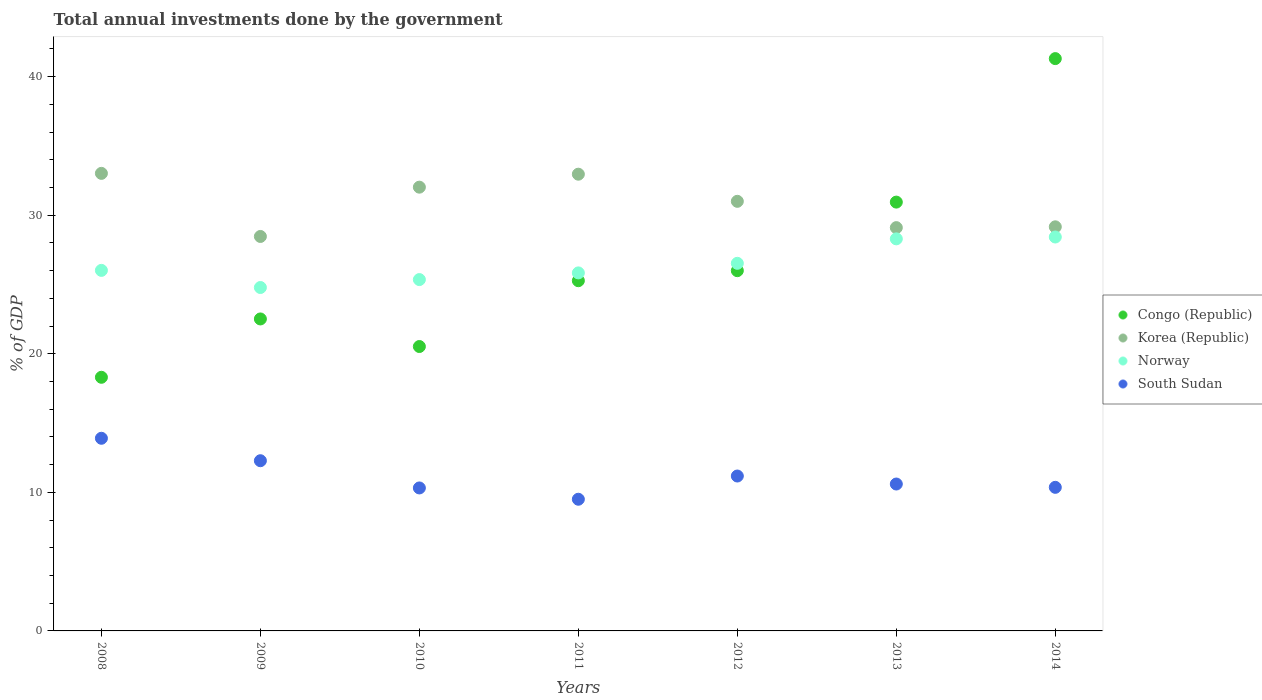Is the number of dotlines equal to the number of legend labels?
Ensure brevity in your answer.  Yes. What is the total annual investments done by the government in Congo (Republic) in 2014?
Your response must be concise. 41.3. Across all years, what is the maximum total annual investments done by the government in Korea (Republic)?
Offer a terse response. 33.02. Across all years, what is the minimum total annual investments done by the government in Congo (Republic)?
Keep it short and to the point. 18.3. In which year was the total annual investments done by the government in Congo (Republic) maximum?
Keep it short and to the point. 2014. What is the total total annual investments done by the government in South Sudan in the graph?
Give a very brief answer. 78.14. What is the difference between the total annual investments done by the government in Congo (Republic) in 2010 and that in 2013?
Offer a terse response. -10.42. What is the difference between the total annual investments done by the government in Congo (Republic) in 2013 and the total annual investments done by the government in Norway in 2014?
Your answer should be compact. 2.52. What is the average total annual investments done by the government in Korea (Republic) per year?
Your answer should be compact. 30.82. In the year 2009, what is the difference between the total annual investments done by the government in Korea (Republic) and total annual investments done by the government in Norway?
Your answer should be compact. 3.68. What is the ratio of the total annual investments done by the government in Norway in 2010 to that in 2011?
Your response must be concise. 0.98. Is the difference between the total annual investments done by the government in Korea (Republic) in 2009 and 2014 greater than the difference between the total annual investments done by the government in Norway in 2009 and 2014?
Provide a succinct answer. Yes. What is the difference between the highest and the second highest total annual investments done by the government in South Sudan?
Ensure brevity in your answer.  1.62. What is the difference between the highest and the lowest total annual investments done by the government in Norway?
Provide a succinct answer. 3.64. Is it the case that in every year, the sum of the total annual investments done by the government in Korea (Republic) and total annual investments done by the government in Norway  is greater than the total annual investments done by the government in South Sudan?
Give a very brief answer. Yes. Does the total annual investments done by the government in Norway monotonically increase over the years?
Your response must be concise. No. Is the total annual investments done by the government in Congo (Republic) strictly greater than the total annual investments done by the government in Korea (Republic) over the years?
Ensure brevity in your answer.  No. How many dotlines are there?
Give a very brief answer. 4. Does the graph contain any zero values?
Ensure brevity in your answer.  No. Does the graph contain grids?
Give a very brief answer. No. Where does the legend appear in the graph?
Your answer should be compact. Center right. What is the title of the graph?
Your answer should be very brief. Total annual investments done by the government. Does "United States" appear as one of the legend labels in the graph?
Keep it short and to the point. No. What is the label or title of the X-axis?
Your answer should be compact. Years. What is the label or title of the Y-axis?
Keep it short and to the point. % of GDP. What is the % of GDP of Congo (Republic) in 2008?
Offer a very short reply. 18.3. What is the % of GDP of Korea (Republic) in 2008?
Provide a short and direct response. 33.02. What is the % of GDP of Norway in 2008?
Your answer should be very brief. 26.02. What is the % of GDP in South Sudan in 2008?
Provide a succinct answer. 13.9. What is the % of GDP of Congo (Republic) in 2009?
Make the answer very short. 22.51. What is the % of GDP in Korea (Republic) in 2009?
Your response must be concise. 28.47. What is the % of GDP in Norway in 2009?
Keep it short and to the point. 24.78. What is the % of GDP in South Sudan in 2009?
Your answer should be very brief. 12.28. What is the % of GDP in Congo (Republic) in 2010?
Ensure brevity in your answer.  20.52. What is the % of GDP of Korea (Republic) in 2010?
Your answer should be very brief. 32.02. What is the % of GDP of Norway in 2010?
Keep it short and to the point. 25.35. What is the % of GDP in South Sudan in 2010?
Give a very brief answer. 10.32. What is the % of GDP in Congo (Republic) in 2011?
Offer a terse response. 25.27. What is the % of GDP of Korea (Republic) in 2011?
Offer a terse response. 32.96. What is the % of GDP of Norway in 2011?
Provide a succinct answer. 25.84. What is the % of GDP of South Sudan in 2011?
Your answer should be compact. 9.5. What is the % of GDP of Congo (Republic) in 2012?
Give a very brief answer. 26. What is the % of GDP in Korea (Republic) in 2012?
Your answer should be very brief. 31. What is the % of GDP of Norway in 2012?
Offer a very short reply. 26.53. What is the % of GDP of South Sudan in 2012?
Provide a short and direct response. 11.18. What is the % of GDP in Congo (Republic) in 2013?
Provide a succinct answer. 30.94. What is the % of GDP in Korea (Republic) in 2013?
Offer a very short reply. 29.1. What is the % of GDP of Norway in 2013?
Provide a succinct answer. 28.29. What is the % of GDP of South Sudan in 2013?
Provide a succinct answer. 10.6. What is the % of GDP in Congo (Republic) in 2014?
Ensure brevity in your answer.  41.3. What is the % of GDP of Korea (Republic) in 2014?
Your answer should be compact. 29.16. What is the % of GDP in Norway in 2014?
Your answer should be very brief. 28.43. What is the % of GDP in South Sudan in 2014?
Make the answer very short. 10.36. Across all years, what is the maximum % of GDP of Congo (Republic)?
Provide a succinct answer. 41.3. Across all years, what is the maximum % of GDP in Korea (Republic)?
Offer a very short reply. 33.02. Across all years, what is the maximum % of GDP of Norway?
Provide a short and direct response. 28.43. Across all years, what is the maximum % of GDP in South Sudan?
Offer a terse response. 13.9. Across all years, what is the minimum % of GDP of Congo (Republic)?
Keep it short and to the point. 18.3. Across all years, what is the minimum % of GDP of Korea (Republic)?
Ensure brevity in your answer.  28.47. Across all years, what is the minimum % of GDP in Norway?
Provide a short and direct response. 24.78. Across all years, what is the minimum % of GDP in South Sudan?
Offer a terse response. 9.5. What is the total % of GDP of Congo (Republic) in the graph?
Give a very brief answer. 184.85. What is the total % of GDP of Korea (Republic) in the graph?
Offer a very short reply. 215.73. What is the total % of GDP in Norway in the graph?
Provide a succinct answer. 185.23. What is the total % of GDP of South Sudan in the graph?
Give a very brief answer. 78.14. What is the difference between the % of GDP of Congo (Republic) in 2008 and that in 2009?
Offer a terse response. -4.21. What is the difference between the % of GDP in Korea (Republic) in 2008 and that in 2009?
Keep it short and to the point. 4.55. What is the difference between the % of GDP in Norway in 2008 and that in 2009?
Ensure brevity in your answer.  1.24. What is the difference between the % of GDP in South Sudan in 2008 and that in 2009?
Your answer should be very brief. 1.62. What is the difference between the % of GDP in Congo (Republic) in 2008 and that in 2010?
Make the answer very short. -2.22. What is the difference between the % of GDP of Norway in 2008 and that in 2010?
Your answer should be compact. 0.66. What is the difference between the % of GDP of South Sudan in 2008 and that in 2010?
Give a very brief answer. 3.58. What is the difference between the % of GDP of Congo (Republic) in 2008 and that in 2011?
Provide a short and direct response. -6.97. What is the difference between the % of GDP in Korea (Republic) in 2008 and that in 2011?
Provide a short and direct response. 0.06. What is the difference between the % of GDP in Norway in 2008 and that in 2011?
Provide a succinct answer. 0.18. What is the difference between the % of GDP in South Sudan in 2008 and that in 2011?
Offer a terse response. 4.4. What is the difference between the % of GDP in Congo (Republic) in 2008 and that in 2012?
Give a very brief answer. -7.69. What is the difference between the % of GDP of Korea (Republic) in 2008 and that in 2012?
Offer a very short reply. 2.02. What is the difference between the % of GDP of Norway in 2008 and that in 2012?
Offer a very short reply. -0.51. What is the difference between the % of GDP of South Sudan in 2008 and that in 2012?
Your answer should be compact. 2.72. What is the difference between the % of GDP of Congo (Republic) in 2008 and that in 2013?
Make the answer very short. -12.64. What is the difference between the % of GDP of Korea (Republic) in 2008 and that in 2013?
Offer a terse response. 3.92. What is the difference between the % of GDP of Norway in 2008 and that in 2013?
Offer a terse response. -2.27. What is the difference between the % of GDP in South Sudan in 2008 and that in 2013?
Give a very brief answer. 3.3. What is the difference between the % of GDP of Congo (Republic) in 2008 and that in 2014?
Your answer should be very brief. -23. What is the difference between the % of GDP in Korea (Republic) in 2008 and that in 2014?
Offer a terse response. 3.86. What is the difference between the % of GDP of Norway in 2008 and that in 2014?
Make the answer very short. -2.41. What is the difference between the % of GDP of South Sudan in 2008 and that in 2014?
Offer a very short reply. 3.54. What is the difference between the % of GDP of Congo (Republic) in 2009 and that in 2010?
Your answer should be compact. 1.99. What is the difference between the % of GDP of Korea (Republic) in 2009 and that in 2010?
Your answer should be very brief. -3.56. What is the difference between the % of GDP in Norway in 2009 and that in 2010?
Ensure brevity in your answer.  -0.57. What is the difference between the % of GDP of South Sudan in 2009 and that in 2010?
Offer a very short reply. 1.97. What is the difference between the % of GDP of Congo (Republic) in 2009 and that in 2011?
Your answer should be compact. -2.76. What is the difference between the % of GDP in Korea (Republic) in 2009 and that in 2011?
Your answer should be very brief. -4.49. What is the difference between the % of GDP in Norway in 2009 and that in 2011?
Your response must be concise. -1.05. What is the difference between the % of GDP in South Sudan in 2009 and that in 2011?
Make the answer very short. 2.78. What is the difference between the % of GDP in Congo (Republic) in 2009 and that in 2012?
Keep it short and to the point. -3.48. What is the difference between the % of GDP in Korea (Republic) in 2009 and that in 2012?
Your answer should be very brief. -2.54. What is the difference between the % of GDP of Norway in 2009 and that in 2012?
Your answer should be compact. -1.75. What is the difference between the % of GDP of South Sudan in 2009 and that in 2012?
Keep it short and to the point. 1.1. What is the difference between the % of GDP of Congo (Republic) in 2009 and that in 2013?
Make the answer very short. -8.43. What is the difference between the % of GDP in Korea (Republic) in 2009 and that in 2013?
Your response must be concise. -0.64. What is the difference between the % of GDP of Norway in 2009 and that in 2013?
Keep it short and to the point. -3.51. What is the difference between the % of GDP in South Sudan in 2009 and that in 2013?
Keep it short and to the point. 1.68. What is the difference between the % of GDP of Congo (Republic) in 2009 and that in 2014?
Ensure brevity in your answer.  -18.79. What is the difference between the % of GDP of Korea (Republic) in 2009 and that in 2014?
Provide a succinct answer. -0.7. What is the difference between the % of GDP of Norway in 2009 and that in 2014?
Keep it short and to the point. -3.64. What is the difference between the % of GDP of South Sudan in 2009 and that in 2014?
Your response must be concise. 1.92. What is the difference between the % of GDP in Congo (Republic) in 2010 and that in 2011?
Your answer should be very brief. -4.75. What is the difference between the % of GDP in Korea (Republic) in 2010 and that in 2011?
Offer a very short reply. -0.94. What is the difference between the % of GDP in Norway in 2010 and that in 2011?
Your response must be concise. -0.48. What is the difference between the % of GDP in South Sudan in 2010 and that in 2011?
Give a very brief answer. 0.82. What is the difference between the % of GDP of Congo (Republic) in 2010 and that in 2012?
Your answer should be compact. -5.47. What is the difference between the % of GDP in Korea (Republic) in 2010 and that in 2012?
Your response must be concise. 1.02. What is the difference between the % of GDP of Norway in 2010 and that in 2012?
Your response must be concise. -1.17. What is the difference between the % of GDP in South Sudan in 2010 and that in 2012?
Provide a succinct answer. -0.86. What is the difference between the % of GDP of Congo (Republic) in 2010 and that in 2013?
Provide a succinct answer. -10.42. What is the difference between the % of GDP of Korea (Republic) in 2010 and that in 2013?
Provide a short and direct response. 2.92. What is the difference between the % of GDP of Norway in 2010 and that in 2013?
Provide a short and direct response. -2.94. What is the difference between the % of GDP of South Sudan in 2010 and that in 2013?
Offer a very short reply. -0.28. What is the difference between the % of GDP of Congo (Republic) in 2010 and that in 2014?
Make the answer very short. -20.78. What is the difference between the % of GDP in Korea (Republic) in 2010 and that in 2014?
Make the answer very short. 2.86. What is the difference between the % of GDP of Norway in 2010 and that in 2014?
Your answer should be very brief. -3.07. What is the difference between the % of GDP of South Sudan in 2010 and that in 2014?
Provide a succinct answer. -0.04. What is the difference between the % of GDP of Congo (Republic) in 2011 and that in 2012?
Your answer should be very brief. -0.72. What is the difference between the % of GDP of Korea (Republic) in 2011 and that in 2012?
Give a very brief answer. 1.96. What is the difference between the % of GDP in Norway in 2011 and that in 2012?
Your answer should be very brief. -0.69. What is the difference between the % of GDP in South Sudan in 2011 and that in 2012?
Your answer should be compact. -1.68. What is the difference between the % of GDP in Congo (Republic) in 2011 and that in 2013?
Make the answer very short. -5.67. What is the difference between the % of GDP of Korea (Republic) in 2011 and that in 2013?
Give a very brief answer. 3.86. What is the difference between the % of GDP of Norway in 2011 and that in 2013?
Keep it short and to the point. -2.46. What is the difference between the % of GDP of South Sudan in 2011 and that in 2013?
Offer a terse response. -1.1. What is the difference between the % of GDP in Congo (Republic) in 2011 and that in 2014?
Offer a terse response. -16.03. What is the difference between the % of GDP in Korea (Republic) in 2011 and that in 2014?
Your response must be concise. 3.8. What is the difference between the % of GDP of Norway in 2011 and that in 2014?
Make the answer very short. -2.59. What is the difference between the % of GDP of South Sudan in 2011 and that in 2014?
Your answer should be compact. -0.86. What is the difference between the % of GDP of Congo (Republic) in 2012 and that in 2013?
Keep it short and to the point. -4.95. What is the difference between the % of GDP in Korea (Republic) in 2012 and that in 2013?
Your answer should be very brief. 1.9. What is the difference between the % of GDP of Norway in 2012 and that in 2013?
Your response must be concise. -1.76. What is the difference between the % of GDP in South Sudan in 2012 and that in 2013?
Make the answer very short. 0.58. What is the difference between the % of GDP in Congo (Republic) in 2012 and that in 2014?
Keep it short and to the point. -15.3. What is the difference between the % of GDP of Korea (Republic) in 2012 and that in 2014?
Offer a terse response. 1.84. What is the difference between the % of GDP of Norway in 2012 and that in 2014?
Offer a very short reply. -1.9. What is the difference between the % of GDP in South Sudan in 2012 and that in 2014?
Offer a very short reply. 0.82. What is the difference between the % of GDP of Congo (Republic) in 2013 and that in 2014?
Your answer should be very brief. -10.36. What is the difference between the % of GDP in Korea (Republic) in 2013 and that in 2014?
Ensure brevity in your answer.  -0.06. What is the difference between the % of GDP of Norway in 2013 and that in 2014?
Ensure brevity in your answer.  -0.13. What is the difference between the % of GDP in South Sudan in 2013 and that in 2014?
Provide a short and direct response. 0.24. What is the difference between the % of GDP of Congo (Republic) in 2008 and the % of GDP of Korea (Republic) in 2009?
Your answer should be compact. -10.16. What is the difference between the % of GDP in Congo (Republic) in 2008 and the % of GDP in Norway in 2009?
Your response must be concise. -6.48. What is the difference between the % of GDP of Congo (Republic) in 2008 and the % of GDP of South Sudan in 2009?
Offer a terse response. 6.02. What is the difference between the % of GDP in Korea (Republic) in 2008 and the % of GDP in Norway in 2009?
Offer a very short reply. 8.24. What is the difference between the % of GDP of Korea (Republic) in 2008 and the % of GDP of South Sudan in 2009?
Your answer should be compact. 20.74. What is the difference between the % of GDP of Norway in 2008 and the % of GDP of South Sudan in 2009?
Your response must be concise. 13.74. What is the difference between the % of GDP in Congo (Republic) in 2008 and the % of GDP in Korea (Republic) in 2010?
Offer a very short reply. -13.72. What is the difference between the % of GDP in Congo (Republic) in 2008 and the % of GDP in Norway in 2010?
Ensure brevity in your answer.  -7.05. What is the difference between the % of GDP of Congo (Republic) in 2008 and the % of GDP of South Sudan in 2010?
Ensure brevity in your answer.  7.99. What is the difference between the % of GDP of Korea (Republic) in 2008 and the % of GDP of Norway in 2010?
Keep it short and to the point. 7.66. What is the difference between the % of GDP of Korea (Republic) in 2008 and the % of GDP of South Sudan in 2010?
Offer a terse response. 22.7. What is the difference between the % of GDP in Norway in 2008 and the % of GDP in South Sudan in 2010?
Give a very brief answer. 15.7. What is the difference between the % of GDP in Congo (Republic) in 2008 and the % of GDP in Korea (Republic) in 2011?
Make the answer very short. -14.66. What is the difference between the % of GDP in Congo (Republic) in 2008 and the % of GDP in Norway in 2011?
Provide a short and direct response. -7.53. What is the difference between the % of GDP in Congo (Republic) in 2008 and the % of GDP in South Sudan in 2011?
Ensure brevity in your answer.  8.8. What is the difference between the % of GDP in Korea (Republic) in 2008 and the % of GDP in Norway in 2011?
Offer a very short reply. 7.18. What is the difference between the % of GDP in Korea (Republic) in 2008 and the % of GDP in South Sudan in 2011?
Give a very brief answer. 23.52. What is the difference between the % of GDP in Norway in 2008 and the % of GDP in South Sudan in 2011?
Make the answer very short. 16.52. What is the difference between the % of GDP of Congo (Republic) in 2008 and the % of GDP of Korea (Republic) in 2012?
Make the answer very short. -12.7. What is the difference between the % of GDP in Congo (Republic) in 2008 and the % of GDP in Norway in 2012?
Provide a succinct answer. -8.22. What is the difference between the % of GDP in Congo (Republic) in 2008 and the % of GDP in South Sudan in 2012?
Your answer should be very brief. 7.13. What is the difference between the % of GDP of Korea (Republic) in 2008 and the % of GDP of Norway in 2012?
Your answer should be compact. 6.49. What is the difference between the % of GDP in Korea (Republic) in 2008 and the % of GDP in South Sudan in 2012?
Your answer should be very brief. 21.84. What is the difference between the % of GDP of Norway in 2008 and the % of GDP of South Sudan in 2012?
Offer a terse response. 14.84. What is the difference between the % of GDP in Congo (Republic) in 2008 and the % of GDP in Korea (Republic) in 2013?
Make the answer very short. -10.8. What is the difference between the % of GDP in Congo (Republic) in 2008 and the % of GDP in Norway in 2013?
Provide a succinct answer. -9.99. What is the difference between the % of GDP in Congo (Republic) in 2008 and the % of GDP in South Sudan in 2013?
Make the answer very short. 7.7. What is the difference between the % of GDP in Korea (Republic) in 2008 and the % of GDP in Norway in 2013?
Keep it short and to the point. 4.73. What is the difference between the % of GDP in Korea (Republic) in 2008 and the % of GDP in South Sudan in 2013?
Provide a succinct answer. 22.42. What is the difference between the % of GDP in Norway in 2008 and the % of GDP in South Sudan in 2013?
Give a very brief answer. 15.42. What is the difference between the % of GDP in Congo (Republic) in 2008 and the % of GDP in Korea (Republic) in 2014?
Provide a succinct answer. -10.86. What is the difference between the % of GDP in Congo (Republic) in 2008 and the % of GDP in Norway in 2014?
Your response must be concise. -10.12. What is the difference between the % of GDP of Congo (Republic) in 2008 and the % of GDP of South Sudan in 2014?
Ensure brevity in your answer.  7.94. What is the difference between the % of GDP of Korea (Republic) in 2008 and the % of GDP of Norway in 2014?
Offer a terse response. 4.59. What is the difference between the % of GDP in Korea (Republic) in 2008 and the % of GDP in South Sudan in 2014?
Your answer should be very brief. 22.66. What is the difference between the % of GDP in Norway in 2008 and the % of GDP in South Sudan in 2014?
Your response must be concise. 15.66. What is the difference between the % of GDP of Congo (Republic) in 2009 and the % of GDP of Korea (Republic) in 2010?
Your answer should be compact. -9.51. What is the difference between the % of GDP in Congo (Republic) in 2009 and the % of GDP in Norway in 2010?
Keep it short and to the point. -2.84. What is the difference between the % of GDP in Congo (Republic) in 2009 and the % of GDP in South Sudan in 2010?
Give a very brief answer. 12.2. What is the difference between the % of GDP in Korea (Republic) in 2009 and the % of GDP in Norway in 2010?
Offer a very short reply. 3.11. What is the difference between the % of GDP in Korea (Republic) in 2009 and the % of GDP in South Sudan in 2010?
Your answer should be compact. 18.15. What is the difference between the % of GDP of Norway in 2009 and the % of GDP of South Sudan in 2010?
Make the answer very short. 14.46. What is the difference between the % of GDP in Congo (Republic) in 2009 and the % of GDP in Korea (Republic) in 2011?
Make the answer very short. -10.45. What is the difference between the % of GDP of Congo (Republic) in 2009 and the % of GDP of Norway in 2011?
Provide a succinct answer. -3.32. What is the difference between the % of GDP in Congo (Republic) in 2009 and the % of GDP in South Sudan in 2011?
Your answer should be compact. 13.01. What is the difference between the % of GDP in Korea (Republic) in 2009 and the % of GDP in Norway in 2011?
Give a very brief answer. 2.63. What is the difference between the % of GDP in Korea (Republic) in 2009 and the % of GDP in South Sudan in 2011?
Provide a succinct answer. 18.96. What is the difference between the % of GDP in Norway in 2009 and the % of GDP in South Sudan in 2011?
Keep it short and to the point. 15.28. What is the difference between the % of GDP of Congo (Republic) in 2009 and the % of GDP of Korea (Republic) in 2012?
Offer a very short reply. -8.49. What is the difference between the % of GDP in Congo (Republic) in 2009 and the % of GDP in Norway in 2012?
Your answer should be very brief. -4.01. What is the difference between the % of GDP in Congo (Republic) in 2009 and the % of GDP in South Sudan in 2012?
Keep it short and to the point. 11.34. What is the difference between the % of GDP in Korea (Republic) in 2009 and the % of GDP in Norway in 2012?
Offer a very short reply. 1.94. What is the difference between the % of GDP of Korea (Republic) in 2009 and the % of GDP of South Sudan in 2012?
Give a very brief answer. 17.29. What is the difference between the % of GDP in Norway in 2009 and the % of GDP in South Sudan in 2012?
Ensure brevity in your answer.  13.6. What is the difference between the % of GDP in Congo (Republic) in 2009 and the % of GDP in Korea (Republic) in 2013?
Ensure brevity in your answer.  -6.59. What is the difference between the % of GDP of Congo (Republic) in 2009 and the % of GDP of Norway in 2013?
Offer a very short reply. -5.78. What is the difference between the % of GDP of Congo (Republic) in 2009 and the % of GDP of South Sudan in 2013?
Give a very brief answer. 11.91. What is the difference between the % of GDP in Korea (Republic) in 2009 and the % of GDP in Norway in 2013?
Provide a succinct answer. 0.17. What is the difference between the % of GDP of Korea (Republic) in 2009 and the % of GDP of South Sudan in 2013?
Keep it short and to the point. 17.86. What is the difference between the % of GDP in Norway in 2009 and the % of GDP in South Sudan in 2013?
Your answer should be compact. 14.18. What is the difference between the % of GDP of Congo (Republic) in 2009 and the % of GDP of Korea (Republic) in 2014?
Your response must be concise. -6.65. What is the difference between the % of GDP in Congo (Republic) in 2009 and the % of GDP in Norway in 2014?
Provide a succinct answer. -5.91. What is the difference between the % of GDP of Congo (Republic) in 2009 and the % of GDP of South Sudan in 2014?
Give a very brief answer. 12.15. What is the difference between the % of GDP of Korea (Republic) in 2009 and the % of GDP of Norway in 2014?
Provide a succinct answer. 0.04. What is the difference between the % of GDP in Korea (Republic) in 2009 and the % of GDP in South Sudan in 2014?
Keep it short and to the point. 18.1. What is the difference between the % of GDP of Norway in 2009 and the % of GDP of South Sudan in 2014?
Your answer should be compact. 14.42. What is the difference between the % of GDP of Congo (Republic) in 2010 and the % of GDP of Korea (Republic) in 2011?
Your answer should be very brief. -12.44. What is the difference between the % of GDP of Congo (Republic) in 2010 and the % of GDP of Norway in 2011?
Offer a terse response. -5.31. What is the difference between the % of GDP of Congo (Republic) in 2010 and the % of GDP of South Sudan in 2011?
Give a very brief answer. 11.02. What is the difference between the % of GDP of Korea (Republic) in 2010 and the % of GDP of Norway in 2011?
Provide a short and direct response. 6.19. What is the difference between the % of GDP of Korea (Republic) in 2010 and the % of GDP of South Sudan in 2011?
Provide a short and direct response. 22.52. What is the difference between the % of GDP of Norway in 2010 and the % of GDP of South Sudan in 2011?
Offer a very short reply. 15.85. What is the difference between the % of GDP of Congo (Republic) in 2010 and the % of GDP of Korea (Republic) in 2012?
Give a very brief answer. -10.48. What is the difference between the % of GDP of Congo (Republic) in 2010 and the % of GDP of Norway in 2012?
Ensure brevity in your answer.  -6. What is the difference between the % of GDP of Congo (Republic) in 2010 and the % of GDP of South Sudan in 2012?
Offer a very short reply. 9.35. What is the difference between the % of GDP in Korea (Republic) in 2010 and the % of GDP in Norway in 2012?
Provide a succinct answer. 5.5. What is the difference between the % of GDP in Korea (Republic) in 2010 and the % of GDP in South Sudan in 2012?
Your answer should be very brief. 20.85. What is the difference between the % of GDP in Norway in 2010 and the % of GDP in South Sudan in 2012?
Provide a succinct answer. 14.18. What is the difference between the % of GDP in Congo (Republic) in 2010 and the % of GDP in Korea (Republic) in 2013?
Your answer should be compact. -8.58. What is the difference between the % of GDP in Congo (Republic) in 2010 and the % of GDP in Norway in 2013?
Your answer should be very brief. -7.77. What is the difference between the % of GDP in Congo (Republic) in 2010 and the % of GDP in South Sudan in 2013?
Keep it short and to the point. 9.92. What is the difference between the % of GDP in Korea (Republic) in 2010 and the % of GDP in Norway in 2013?
Keep it short and to the point. 3.73. What is the difference between the % of GDP in Korea (Republic) in 2010 and the % of GDP in South Sudan in 2013?
Make the answer very short. 21.42. What is the difference between the % of GDP in Norway in 2010 and the % of GDP in South Sudan in 2013?
Your response must be concise. 14.75. What is the difference between the % of GDP in Congo (Republic) in 2010 and the % of GDP in Korea (Republic) in 2014?
Keep it short and to the point. -8.64. What is the difference between the % of GDP of Congo (Republic) in 2010 and the % of GDP of Norway in 2014?
Make the answer very short. -7.9. What is the difference between the % of GDP in Congo (Republic) in 2010 and the % of GDP in South Sudan in 2014?
Make the answer very short. 10.16. What is the difference between the % of GDP in Korea (Republic) in 2010 and the % of GDP in Norway in 2014?
Your answer should be compact. 3.6. What is the difference between the % of GDP in Korea (Republic) in 2010 and the % of GDP in South Sudan in 2014?
Give a very brief answer. 21.66. What is the difference between the % of GDP in Norway in 2010 and the % of GDP in South Sudan in 2014?
Give a very brief answer. 14.99. What is the difference between the % of GDP of Congo (Republic) in 2011 and the % of GDP of Korea (Republic) in 2012?
Provide a short and direct response. -5.73. What is the difference between the % of GDP of Congo (Republic) in 2011 and the % of GDP of Norway in 2012?
Your response must be concise. -1.26. What is the difference between the % of GDP in Congo (Republic) in 2011 and the % of GDP in South Sudan in 2012?
Offer a terse response. 14.09. What is the difference between the % of GDP in Korea (Republic) in 2011 and the % of GDP in Norway in 2012?
Your response must be concise. 6.43. What is the difference between the % of GDP in Korea (Republic) in 2011 and the % of GDP in South Sudan in 2012?
Offer a terse response. 21.78. What is the difference between the % of GDP in Norway in 2011 and the % of GDP in South Sudan in 2012?
Give a very brief answer. 14.66. What is the difference between the % of GDP of Congo (Republic) in 2011 and the % of GDP of Korea (Republic) in 2013?
Offer a terse response. -3.83. What is the difference between the % of GDP of Congo (Republic) in 2011 and the % of GDP of Norway in 2013?
Ensure brevity in your answer.  -3.02. What is the difference between the % of GDP of Congo (Republic) in 2011 and the % of GDP of South Sudan in 2013?
Ensure brevity in your answer.  14.67. What is the difference between the % of GDP in Korea (Republic) in 2011 and the % of GDP in Norway in 2013?
Offer a very short reply. 4.67. What is the difference between the % of GDP of Korea (Republic) in 2011 and the % of GDP of South Sudan in 2013?
Provide a succinct answer. 22.36. What is the difference between the % of GDP of Norway in 2011 and the % of GDP of South Sudan in 2013?
Make the answer very short. 15.23. What is the difference between the % of GDP of Congo (Republic) in 2011 and the % of GDP of Korea (Republic) in 2014?
Your response must be concise. -3.89. What is the difference between the % of GDP in Congo (Republic) in 2011 and the % of GDP in Norway in 2014?
Provide a succinct answer. -3.15. What is the difference between the % of GDP of Congo (Republic) in 2011 and the % of GDP of South Sudan in 2014?
Give a very brief answer. 14.91. What is the difference between the % of GDP of Korea (Republic) in 2011 and the % of GDP of Norway in 2014?
Your answer should be compact. 4.53. What is the difference between the % of GDP in Korea (Republic) in 2011 and the % of GDP in South Sudan in 2014?
Your response must be concise. 22.6. What is the difference between the % of GDP of Norway in 2011 and the % of GDP of South Sudan in 2014?
Your response must be concise. 15.47. What is the difference between the % of GDP of Congo (Republic) in 2012 and the % of GDP of Korea (Republic) in 2013?
Offer a terse response. -3.11. What is the difference between the % of GDP in Congo (Republic) in 2012 and the % of GDP in Norway in 2013?
Provide a succinct answer. -2.3. What is the difference between the % of GDP of Congo (Republic) in 2012 and the % of GDP of South Sudan in 2013?
Provide a short and direct response. 15.4. What is the difference between the % of GDP in Korea (Republic) in 2012 and the % of GDP in Norway in 2013?
Provide a short and direct response. 2.71. What is the difference between the % of GDP of Korea (Republic) in 2012 and the % of GDP of South Sudan in 2013?
Make the answer very short. 20.4. What is the difference between the % of GDP of Norway in 2012 and the % of GDP of South Sudan in 2013?
Keep it short and to the point. 15.93. What is the difference between the % of GDP of Congo (Republic) in 2012 and the % of GDP of Korea (Republic) in 2014?
Provide a succinct answer. -3.16. What is the difference between the % of GDP in Congo (Republic) in 2012 and the % of GDP in Norway in 2014?
Provide a succinct answer. -2.43. What is the difference between the % of GDP in Congo (Republic) in 2012 and the % of GDP in South Sudan in 2014?
Keep it short and to the point. 15.63. What is the difference between the % of GDP in Korea (Republic) in 2012 and the % of GDP in Norway in 2014?
Ensure brevity in your answer.  2.58. What is the difference between the % of GDP in Korea (Republic) in 2012 and the % of GDP in South Sudan in 2014?
Ensure brevity in your answer.  20.64. What is the difference between the % of GDP of Norway in 2012 and the % of GDP of South Sudan in 2014?
Provide a short and direct response. 16.17. What is the difference between the % of GDP in Congo (Republic) in 2013 and the % of GDP in Korea (Republic) in 2014?
Your response must be concise. 1.78. What is the difference between the % of GDP of Congo (Republic) in 2013 and the % of GDP of Norway in 2014?
Give a very brief answer. 2.52. What is the difference between the % of GDP in Congo (Republic) in 2013 and the % of GDP in South Sudan in 2014?
Ensure brevity in your answer.  20.58. What is the difference between the % of GDP in Korea (Republic) in 2013 and the % of GDP in Norway in 2014?
Your response must be concise. 0.68. What is the difference between the % of GDP in Korea (Republic) in 2013 and the % of GDP in South Sudan in 2014?
Give a very brief answer. 18.74. What is the difference between the % of GDP of Norway in 2013 and the % of GDP of South Sudan in 2014?
Offer a terse response. 17.93. What is the average % of GDP in Congo (Republic) per year?
Your answer should be compact. 26.41. What is the average % of GDP in Korea (Republic) per year?
Offer a very short reply. 30.82. What is the average % of GDP of Norway per year?
Offer a very short reply. 26.46. What is the average % of GDP of South Sudan per year?
Your answer should be compact. 11.16. In the year 2008, what is the difference between the % of GDP in Congo (Republic) and % of GDP in Korea (Republic)?
Your answer should be compact. -14.72. In the year 2008, what is the difference between the % of GDP of Congo (Republic) and % of GDP of Norway?
Ensure brevity in your answer.  -7.71. In the year 2008, what is the difference between the % of GDP of Congo (Republic) and % of GDP of South Sudan?
Make the answer very short. 4.4. In the year 2008, what is the difference between the % of GDP of Korea (Republic) and % of GDP of Norway?
Offer a terse response. 7. In the year 2008, what is the difference between the % of GDP in Korea (Republic) and % of GDP in South Sudan?
Your answer should be compact. 19.12. In the year 2008, what is the difference between the % of GDP in Norway and % of GDP in South Sudan?
Ensure brevity in your answer.  12.12. In the year 2009, what is the difference between the % of GDP of Congo (Republic) and % of GDP of Korea (Republic)?
Give a very brief answer. -5.95. In the year 2009, what is the difference between the % of GDP of Congo (Republic) and % of GDP of Norway?
Make the answer very short. -2.27. In the year 2009, what is the difference between the % of GDP of Congo (Republic) and % of GDP of South Sudan?
Your answer should be very brief. 10.23. In the year 2009, what is the difference between the % of GDP in Korea (Republic) and % of GDP in Norway?
Provide a succinct answer. 3.68. In the year 2009, what is the difference between the % of GDP in Korea (Republic) and % of GDP in South Sudan?
Your answer should be compact. 16.18. In the year 2009, what is the difference between the % of GDP of Norway and % of GDP of South Sudan?
Provide a short and direct response. 12.5. In the year 2010, what is the difference between the % of GDP in Congo (Republic) and % of GDP in Korea (Republic)?
Make the answer very short. -11.5. In the year 2010, what is the difference between the % of GDP in Congo (Republic) and % of GDP in Norway?
Keep it short and to the point. -4.83. In the year 2010, what is the difference between the % of GDP of Congo (Republic) and % of GDP of South Sudan?
Make the answer very short. 10.21. In the year 2010, what is the difference between the % of GDP of Korea (Republic) and % of GDP of Norway?
Your answer should be very brief. 6.67. In the year 2010, what is the difference between the % of GDP in Korea (Republic) and % of GDP in South Sudan?
Provide a succinct answer. 21.71. In the year 2010, what is the difference between the % of GDP of Norway and % of GDP of South Sudan?
Offer a terse response. 15.04. In the year 2011, what is the difference between the % of GDP in Congo (Republic) and % of GDP in Korea (Republic)?
Ensure brevity in your answer.  -7.69. In the year 2011, what is the difference between the % of GDP of Congo (Republic) and % of GDP of Norway?
Your answer should be very brief. -0.56. In the year 2011, what is the difference between the % of GDP of Congo (Republic) and % of GDP of South Sudan?
Make the answer very short. 15.77. In the year 2011, what is the difference between the % of GDP in Korea (Republic) and % of GDP in Norway?
Your answer should be compact. 7.12. In the year 2011, what is the difference between the % of GDP in Korea (Republic) and % of GDP in South Sudan?
Offer a terse response. 23.46. In the year 2011, what is the difference between the % of GDP of Norway and % of GDP of South Sudan?
Provide a succinct answer. 16.33. In the year 2012, what is the difference between the % of GDP in Congo (Republic) and % of GDP in Korea (Republic)?
Ensure brevity in your answer.  -5. In the year 2012, what is the difference between the % of GDP of Congo (Republic) and % of GDP of Norway?
Your answer should be very brief. -0.53. In the year 2012, what is the difference between the % of GDP of Congo (Republic) and % of GDP of South Sudan?
Your answer should be very brief. 14.82. In the year 2012, what is the difference between the % of GDP in Korea (Republic) and % of GDP in Norway?
Give a very brief answer. 4.47. In the year 2012, what is the difference between the % of GDP of Korea (Republic) and % of GDP of South Sudan?
Offer a terse response. 19.82. In the year 2012, what is the difference between the % of GDP of Norway and % of GDP of South Sudan?
Make the answer very short. 15.35. In the year 2013, what is the difference between the % of GDP in Congo (Republic) and % of GDP in Korea (Republic)?
Ensure brevity in your answer.  1.84. In the year 2013, what is the difference between the % of GDP in Congo (Republic) and % of GDP in Norway?
Give a very brief answer. 2.65. In the year 2013, what is the difference between the % of GDP in Congo (Republic) and % of GDP in South Sudan?
Your answer should be very brief. 20.34. In the year 2013, what is the difference between the % of GDP in Korea (Republic) and % of GDP in Norway?
Offer a very short reply. 0.81. In the year 2013, what is the difference between the % of GDP in Korea (Republic) and % of GDP in South Sudan?
Keep it short and to the point. 18.5. In the year 2013, what is the difference between the % of GDP of Norway and % of GDP of South Sudan?
Offer a very short reply. 17.69. In the year 2014, what is the difference between the % of GDP in Congo (Republic) and % of GDP in Korea (Republic)?
Your answer should be compact. 12.14. In the year 2014, what is the difference between the % of GDP of Congo (Republic) and % of GDP of Norway?
Offer a terse response. 12.87. In the year 2014, what is the difference between the % of GDP of Congo (Republic) and % of GDP of South Sudan?
Your answer should be very brief. 30.94. In the year 2014, what is the difference between the % of GDP of Korea (Republic) and % of GDP of Norway?
Ensure brevity in your answer.  0.74. In the year 2014, what is the difference between the % of GDP of Korea (Republic) and % of GDP of South Sudan?
Your answer should be compact. 18.8. In the year 2014, what is the difference between the % of GDP in Norway and % of GDP in South Sudan?
Provide a short and direct response. 18.06. What is the ratio of the % of GDP of Congo (Republic) in 2008 to that in 2009?
Ensure brevity in your answer.  0.81. What is the ratio of the % of GDP of Korea (Republic) in 2008 to that in 2009?
Your response must be concise. 1.16. What is the ratio of the % of GDP in Norway in 2008 to that in 2009?
Offer a terse response. 1.05. What is the ratio of the % of GDP in South Sudan in 2008 to that in 2009?
Your answer should be very brief. 1.13. What is the ratio of the % of GDP of Congo (Republic) in 2008 to that in 2010?
Provide a short and direct response. 0.89. What is the ratio of the % of GDP of Korea (Republic) in 2008 to that in 2010?
Your answer should be compact. 1.03. What is the ratio of the % of GDP in Norway in 2008 to that in 2010?
Keep it short and to the point. 1.03. What is the ratio of the % of GDP in South Sudan in 2008 to that in 2010?
Your answer should be compact. 1.35. What is the ratio of the % of GDP of Congo (Republic) in 2008 to that in 2011?
Keep it short and to the point. 0.72. What is the ratio of the % of GDP in Korea (Republic) in 2008 to that in 2011?
Provide a succinct answer. 1. What is the ratio of the % of GDP in Norway in 2008 to that in 2011?
Your response must be concise. 1.01. What is the ratio of the % of GDP in South Sudan in 2008 to that in 2011?
Provide a succinct answer. 1.46. What is the ratio of the % of GDP in Congo (Republic) in 2008 to that in 2012?
Offer a very short reply. 0.7. What is the ratio of the % of GDP in Korea (Republic) in 2008 to that in 2012?
Your answer should be compact. 1.07. What is the ratio of the % of GDP of Norway in 2008 to that in 2012?
Provide a succinct answer. 0.98. What is the ratio of the % of GDP in South Sudan in 2008 to that in 2012?
Give a very brief answer. 1.24. What is the ratio of the % of GDP of Congo (Republic) in 2008 to that in 2013?
Give a very brief answer. 0.59. What is the ratio of the % of GDP in Korea (Republic) in 2008 to that in 2013?
Make the answer very short. 1.13. What is the ratio of the % of GDP of Norway in 2008 to that in 2013?
Make the answer very short. 0.92. What is the ratio of the % of GDP in South Sudan in 2008 to that in 2013?
Make the answer very short. 1.31. What is the ratio of the % of GDP in Congo (Republic) in 2008 to that in 2014?
Make the answer very short. 0.44. What is the ratio of the % of GDP in Korea (Republic) in 2008 to that in 2014?
Provide a short and direct response. 1.13. What is the ratio of the % of GDP of Norway in 2008 to that in 2014?
Make the answer very short. 0.92. What is the ratio of the % of GDP in South Sudan in 2008 to that in 2014?
Your answer should be very brief. 1.34. What is the ratio of the % of GDP in Congo (Republic) in 2009 to that in 2010?
Your answer should be compact. 1.1. What is the ratio of the % of GDP in Korea (Republic) in 2009 to that in 2010?
Offer a terse response. 0.89. What is the ratio of the % of GDP in Norway in 2009 to that in 2010?
Offer a very short reply. 0.98. What is the ratio of the % of GDP in South Sudan in 2009 to that in 2010?
Offer a terse response. 1.19. What is the ratio of the % of GDP of Congo (Republic) in 2009 to that in 2011?
Make the answer very short. 0.89. What is the ratio of the % of GDP of Korea (Republic) in 2009 to that in 2011?
Offer a very short reply. 0.86. What is the ratio of the % of GDP of Norway in 2009 to that in 2011?
Your response must be concise. 0.96. What is the ratio of the % of GDP in South Sudan in 2009 to that in 2011?
Make the answer very short. 1.29. What is the ratio of the % of GDP of Congo (Republic) in 2009 to that in 2012?
Your response must be concise. 0.87. What is the ratio of the % of GDP of Korea (Republic) in 2009 to that in 2012?
Offer a very short reply. 0.92. What is the ratio of the % of GDP of Norway in 2009 to that in 2012?
Provide a short and direct response. 0.93. What is the ratio of the % of GDP of South Sudan in 2009 to that in 2012?
Ensure brevity in your answer.  1.1. What is the ratio of the % of GDP of Congo (Republic) in 2009 to that in 2013?
Provide a succinct answer. 0.73. What is the ratio of the % of GDP in Korea (Republic) in 2009 to that in 2013?
Keep it short and to the point. 0.98. What is the ratio of the % of GDP of Norway in 2009 to that in 2013?
Make the answer very short. 0.88. What is the ratio of the % of GDP in South Sudan in 2009 to that in 2013?
Give a very brief answer. 1.16. What is the ratio of the % of GDP of Congo (Republic) in 2009 to that in 2014?
Provide a short and direct response. 0.55. What is the ratio of the % of GDP of Korea (Republic) in 2009 to that in 2014?
Your answer should be compact. 0.98. What is the ratio of the % of GDP in Norway in 2009 to that in 2014?
Give a very brief answer. 0.87. What is the ratio of the % of GDP of South Sudan in 2009 to that in 2014?
Your answer should be very brief. 1.19. What is the ratio of the % of GDP of Congo (Republic) in 2010 to that in 2011?
Offer a very short reply. 0.81. What is the ratio of the % of GDP of Korea (Republic) in 2010 to that in 2011?
Ensure brevity in your answer.  0.97. What is the ratio of the % of GDP in Norway in 2010 to that in 2011?
Keep it short and to the point. 0.98. What is the ratio of the % of GDP in South Sudan in 2010 to that in 2011?
Offer a very short reply. 1.09. What is the ratio of the % of GDP in Congo (Republic) in 2010 to that in 2012?
Your response must be concise. 0.79. What is the ratio of the % of GDP of Korea (Republic) in 2010 to that in 2012?
Give a very brief answer. 1.03. What is the ratio of the % of GDP of Norway in 2010 to that in 2012?
Your response must be concise. 0.96. What is the ratio of the % of GDP of South Sudan in 2010 to that in 2012?
Give a very brief answer. 0.92. What is the ratio of the % of GDP in Congo (Republic) in 2010 to that in 2013?
Make the answer very short. 0.66. What is the ratio of the % of GDP in Korea (Republic) in 2010 to that in 2013?
Keep it short and to the point. 1.1. What is the ratio of the % of GDP in Norway in 2010 to that in 2013?
Keep it short and to the point. 0.9. What is the ratio of the % of GDP in South Sudan in 2010 to that in 2013?
Keep it short and to the point. 0.97. What is the ratio of the % of GDP in Congo (Republic) in 2010 to that in 2014?
Offer a terse response. 0.5. What is the ratio of the % of GDP in Korea (Republic) in 2010 to that in 2014?
Your answer should be very brief. 1.1. What is the ratio of the % of GDP of Norway in 2010 to that in 2014?
Your response must be concise. 0.89. What is the ratio of the % of GDP in South Sudan in 2010 to that in 2014?
Keep it short and to the point. 1. What is the ratio of the % of GDP of Congo (Republic) in 2011 to that in 2012?
Your answer should be very brief. 0.97. What is the ratio of the % of GDP in Korea (Republic) in 2011 to that in 2012?
Offer a very short reply. 1.06. What is the ratio of the % of GDP of Norway in 2011 to that in 2012?
Make the answer very short. 0.97. What is the ratio of the % of GDP of South Sudan in 2011 to that in 2012?
Ensure brevity in your answer.  0.85. What is the ratio of the % of GDP in Congo (Republic) in 2011 to that in 2013?
Give a very brief answer. 0.82. What is the ratio of the % of GDP of Korea (Republic) in 2011 to that in 2013?
Offer a terse response. 1.13. What is the ratio of the % of GDP of Norway in 2011 to that in 2013?
Keep it short and to the point. 0.91. What is the ratio of the % of GDP of South Sudan in 2011 to that in 2013?
Ensure brevity in your answer.  0.9. What is the ratio of the % of GDP of Congo (Republic) in 2011 to that in 2014?
Your response must be concise. 0.61. What is the ratio of the % of GDP of Korea (Republic) in 2011 to that in 2014?
Ensure brevity in your answer.  1.13. What is the ratio of the % of GDP in Norway in 2011 to that in 2014?
Your response must be concise. 0.91. What is the ratio of the % of GDP of South Sudan in 2011 to that in 2014?
Your answer should be very brief. 0.92. What is the ratio of the % of GDP in Congo (Republic) in 2012 to that in 2013?
Your response must be concise. 0.84. What is the ratio of the % of GDP of Korea (Republic) in 2012 to that in 2013?
Make the answer very short. 1.07. What is the ratio of the % of GDP of Norway in 2012 to that in 2013?
Make the answer very short. 0.94. What is the ratio of the % of GDP of South Sudan in 2012 to that in 2013?
Your answer should be very brief. 1.05. What is the ratio of the % of GDP of Congo (Republic) in 2012 to that in 2014?
Your answer should be very brief. 0.63. What is the ratio of the % of GDP of Korea (Republic) in 2012 to that in 2014?
Keep it short and to the point. 1.06. What is the ratio of the % of GDP in Norway in 2012 to that in 2014?
Your response must be concise. 0.93. What is the ratio of the % of GDP of South Sudan in 2012 to that in 2014?
Provide a succinct answer. 1.08. What is the ratio of the % of GDP of Congo (Republic) in 2013 to that in 2014?
Your answer should be compact. 0.75. What is the ratio of the % of GDP of Korea (Republic) in 2013 to that in 2014?
Make the answer very short. 1. What is the ratio of the % of GDP of Norway in 2013 to that in 2014?
Keep it short and to the point. 1. What is the ratio of the % of GDP in South Sudan in 2013 to that in 2014?
Keep it short and to the point. 1.02. What is the difference between the highest and the second highest % of GDP of Congo (Republic)?
Make the answer very short. 10.36. What is the difference between the highest and the second highest % of GDP in Korea (Republic)?
Make the answer very short. 0.06. What is the difference between the highest and the second highest % of GDP in Norway?
Give a very brief answer. 0.13. What is the difference between the highest and the second highest % of GDP in South Sudan?
Offer a terse response. 1.62. What is the difference between the highest and the lowest % of GDP of Congo (Republic)?
Your answer should be compact. 23. What is the difference between the highest and the lowest % of GDP in Korea (Republic)?
Ensure brevity in your answer.  4.55. What is the difference between the highest and the lowest % of GDP of Norway?
Provide a succinct answer. 3.64. What is the difference between the highest and the lowest % of GDP of South Sudan?
Offer a very short reply. 4.4. 